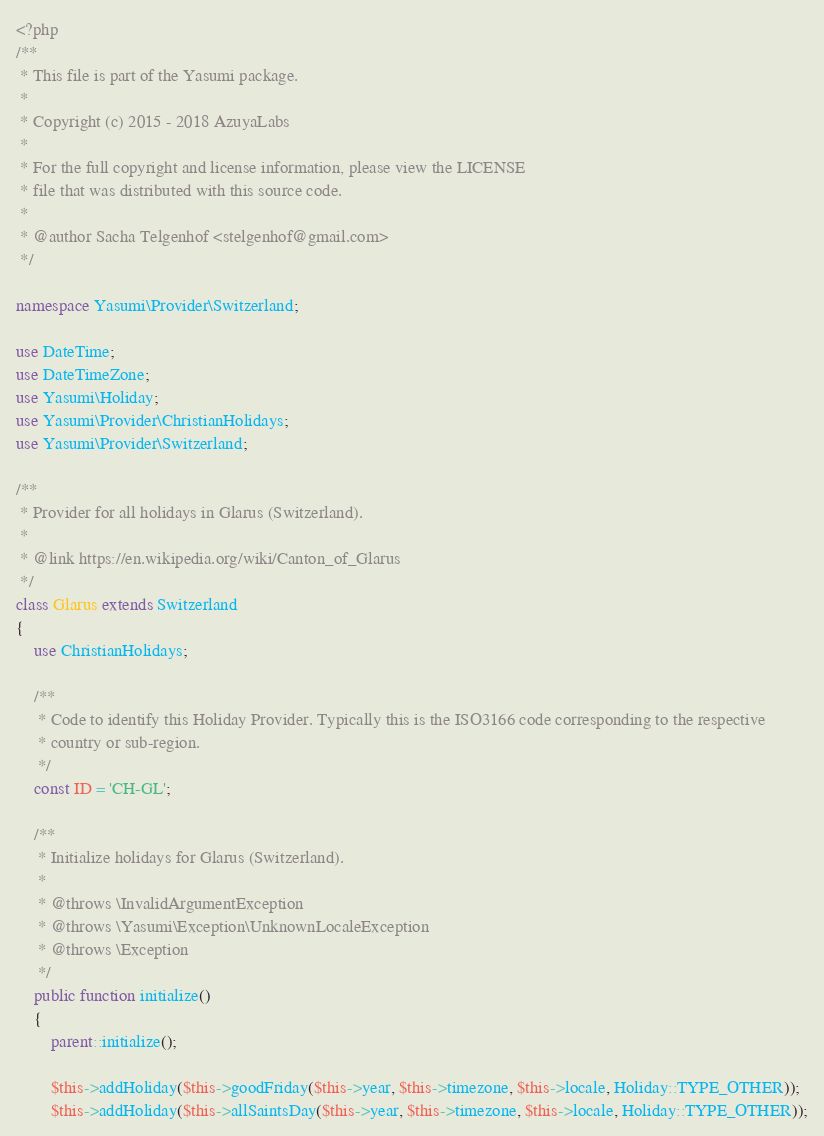Convert code to text. <code><loc_0><loc_0><loc_500><loc_500><_PHP_><?php
/**
 * This file is part of the Yasumi package.
 *
 * Copyright (c) 2015 - 2018 AzuyaLabs
 *
 * For the full copyright and license information, please view the LICENSE
 * file that was distributed with this source code.
 *
 * @author Sacha Telgenhof <stelgenhof@gmail.com>
 */

namespace Yasumi\Provider\Switzerland;

use DateTime;
use DateTimeZone;
use Yasumi\Holiday;
use Yasumi\Provider\ChristianHolidays;
use Yasumi\Provider\Switzerland;

/**
 * Provider for all holidays in Glarus (Switzerland).
 *
 * @link https://en.wikipedia.org/wiki/Canton_of_Glarus
 */
class Glarus extends Switzerland
{
    use ChristianHolidays;

    /**
     * Code to identify this Holiday Provider. Typically this is the ISO3166 code corresponding to the respective
     * country or sub-region.
     */
    const ID = 'CH-GL';

    /**
     * Initialize holidays for Glarus (Switzerland).
     *
     * @throws \InvalidArgumentException
     * @throws \Yasumi\Exception\UnknownLocaleException
     * @throws \Exception
     */
    public function initialize()
    {
        parent::initialize();

        $this->addHoliday($this->goodFriday($this->year, $this->timezone, $this->locale, Holiday::TYPE_OTHER));
        $this->addHoliday($this->allSaintsDay($this->year, $this->timezone, $this->locale, Holiday::TYPE_OTHER));</code> 